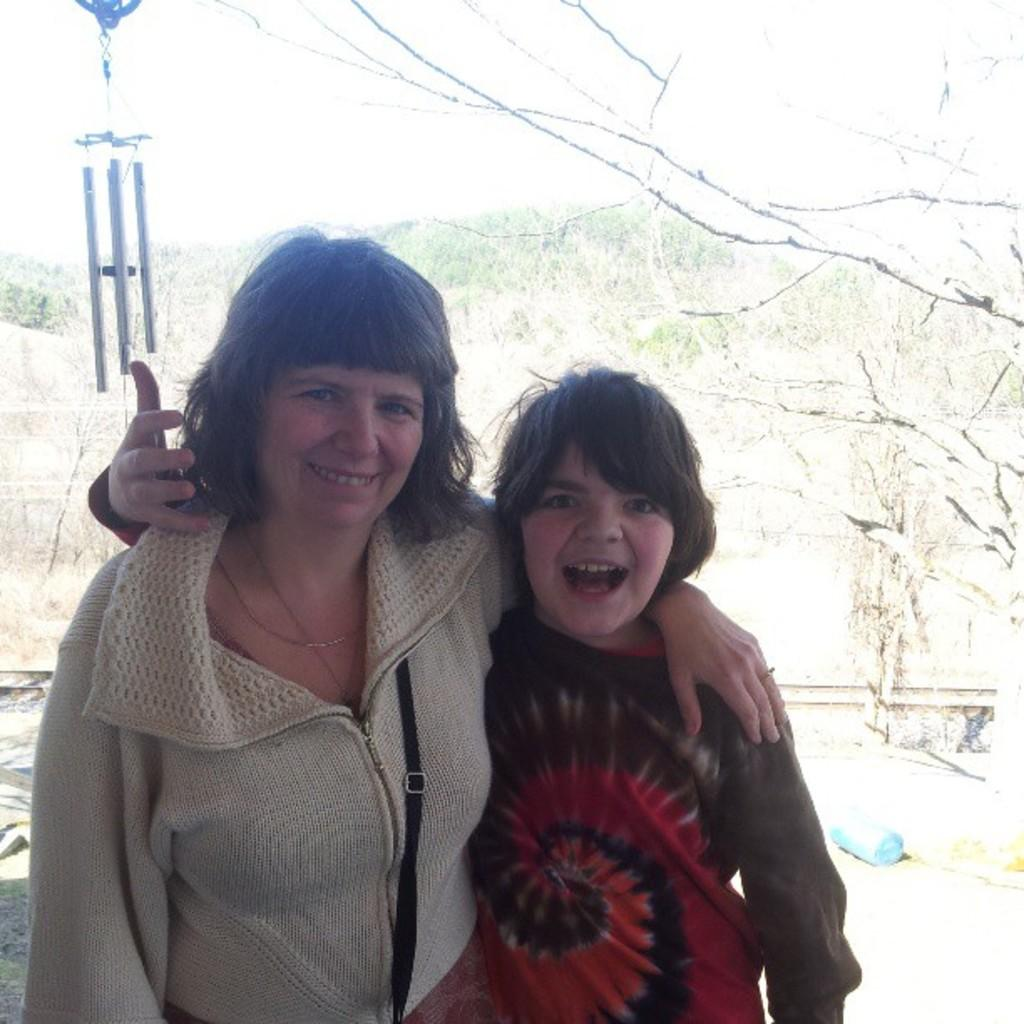Who is present in the image? There is a woman and a boy in the image. What expressions do they have? Both the woman and the boy are smiling. What can be seen in the background of the image? There are trees, a fence, a blue color object, grass, poles, and the sky visible in the background of the image. What type of dirt can be seen on the woman's shoes in the image? There is no dirt visible on the woman's shoes in the image. What hope does the boy have for the future in the image? The image does not provide any information about the boy's hopes for the future. 